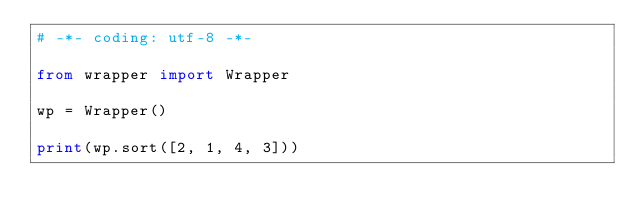Convert code to text. <code><loc_0><loc_0><loc_500><loc_500><_Python_># -*- coding: utf-8 -*-

from wrapper import Wrapper

wp = Wrapper()

print(wp.sort([2, 1, 4, 3]))
</code> 